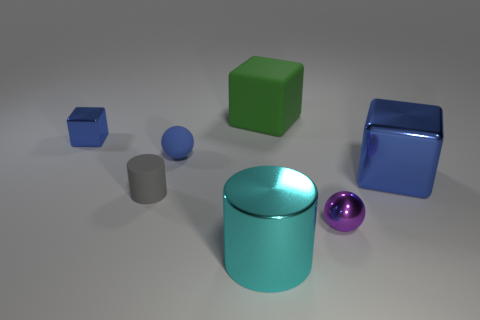The cylinder that is the same material as the big green thing is what size?
Your response must be concise. Small. What number of things are yellow shiny cubes or cyan shiny cylinders?
Give a very brief answer. 1. What is the color of the ball left of the big cyan cylinder?
Your answer should be compact. Blue. What size is the gray matte object that is the same shape as the cyan shiny object?
Your answer should be compact. Small. What number of things are either large things that are behind the big blue block or tiny metallic things that are to the left of the gray matte cylinder?
Offer a very short reply. 2. How big is the thing that is behind the tiny gray cylinder and on the left side of the tiny blue matte sphere?
Provide a short and direct response. Small. Do the blue matte thing and the tiny metallic thing in front of the small blue metallic thing have the same shape?
Provide a succinct answer. Yes. How many objects are objects that are right of the blue matte sphere or small blue metal things?
Your response must be concise. 5. Is the material of the gray cylinder the same as the large block on the right side of the purple object?
Make the answer very short. No. What shape is the matte thing in front of the blue shiny cube to the right of the big green object?
Offer a terse response. Cylinder. 